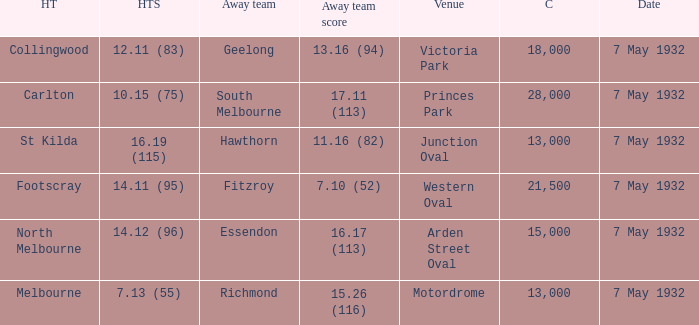Which home team has hawthorn as their away team? St Kilda. 